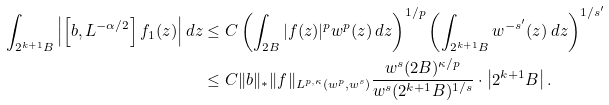<formula> <loc_0><loc_0><loc_500><loc_500>\int _ { 2 ^ { k + 1 } B } \left | \left [ b , L ^ { - \alpha / 2 } \right ] f _ { 1 } ( z ) \right | d z & \leq C \left ( \int _ { 2 B } | f ( z ) | ^ { p } w ^ { p } ( z ) \, d z \right ) ^ { 1 / p } \left ( \int _ { 2 ^ { k + 1 } B } w ^ { - s ^ { \prime } } ( z ) \, d z \right ) ^ { 1 / { s ^ { \prime } } } \\ & \leq C \| b \| _ { * } \| f \| _ { L ^ { p , \kappa } ( w ^ { p } , w ^ { s } ) } \frac { w ^ { s } ( 2 B ) ^ { \kappa / p } } { w ^ { s } ( 2 ^ { k + 1 } B ) ^ { 1 / s } } \cdot \left | 2 ^ { k + 1 } B \right | .</formula> 